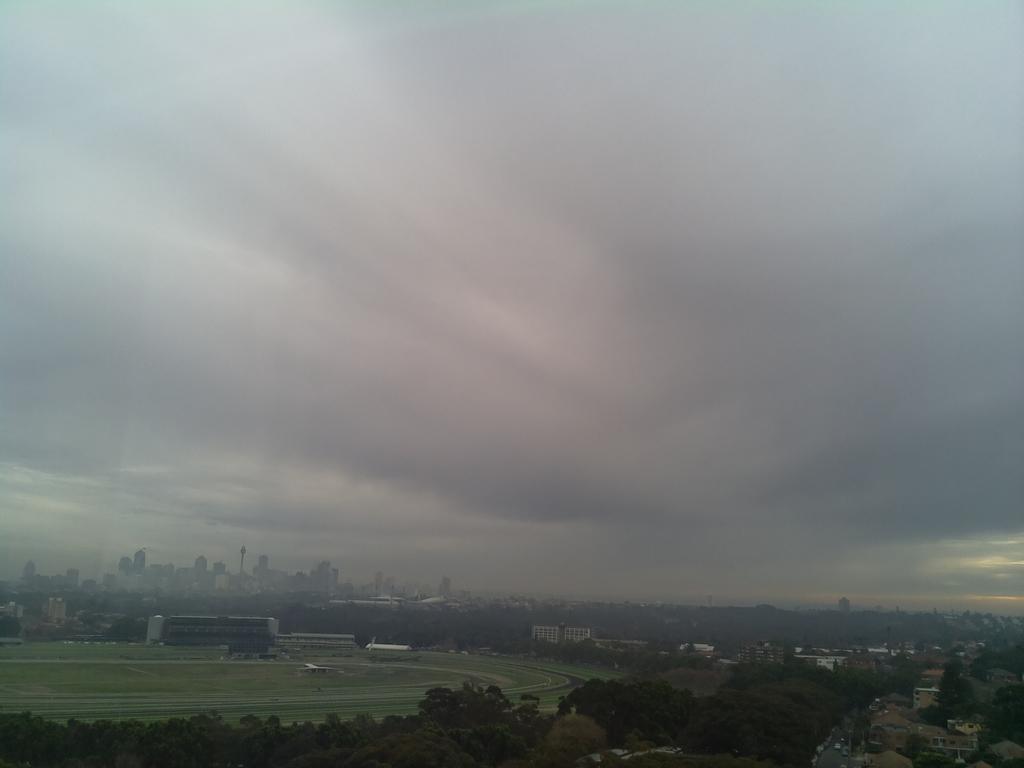In one or two sentences, can you explain what this image depicts? In this picture we can see trees, buildings and in the background we can see the sky with clouds. 